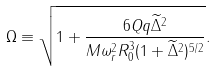Convert formula to latex. <formula><loc_0><loc_0><loc_500><loc_500>\Omega \equiv \sqrt { 1 + \frac { 6 Q q \widetilde { \Delta } ^ { 2 } } { M \omega _ { r } ^ { 2 } R _ { 0 } ^ { 3 } ( 1 + \widetilde { \Delta } ^ { 2 } ) ^ { 5 / 2 } } } .</formula> 